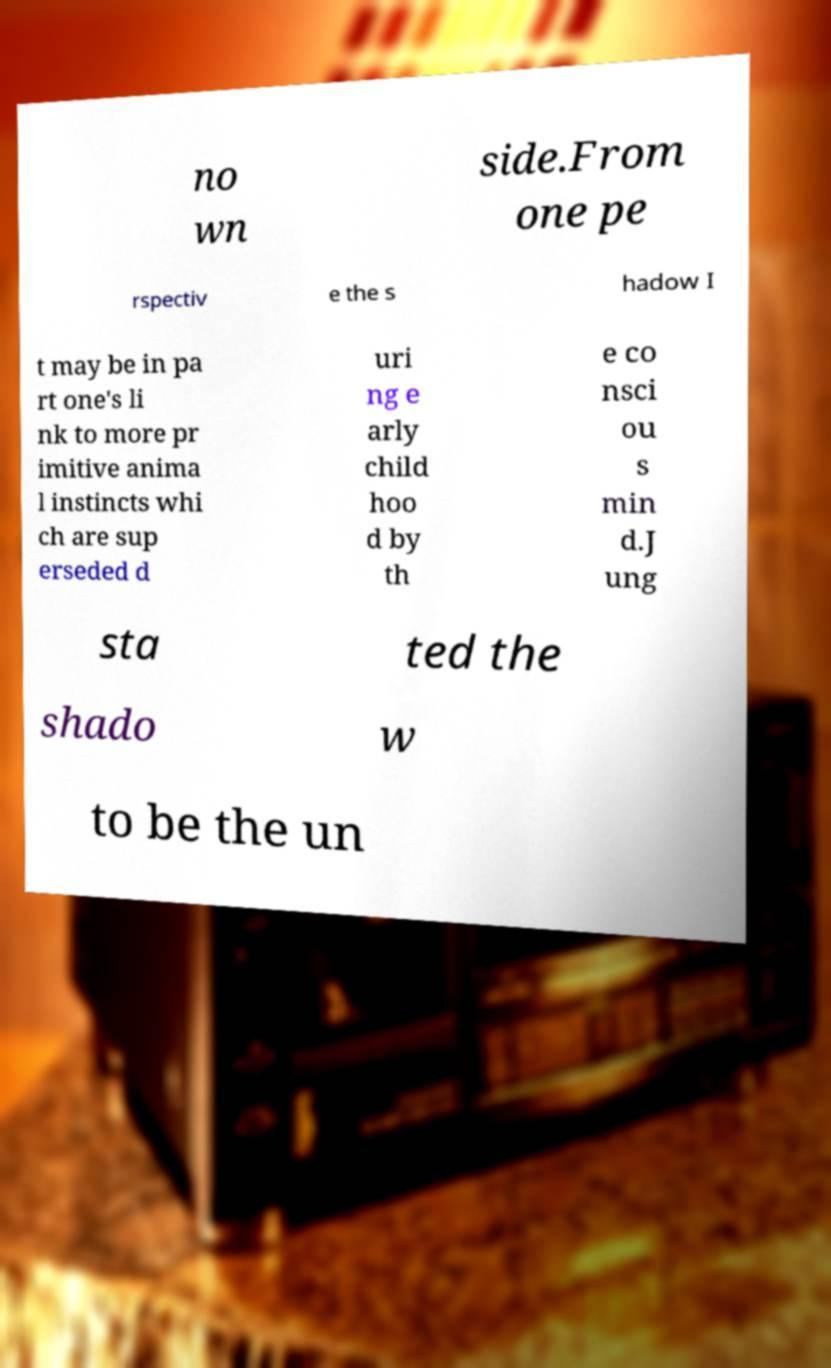There's text embedded in this image that I need extracted. Can you transcribe it verbatim? no wn side.From one pe rspectiv e the s hadow I t may be in pa rt one's li nk to more pr imitive anima l instincts whi ch are sup erseded d uri ng e arly child hoo d by th e co nsci ou s min d.J ung sta ted the shado w to be the un 